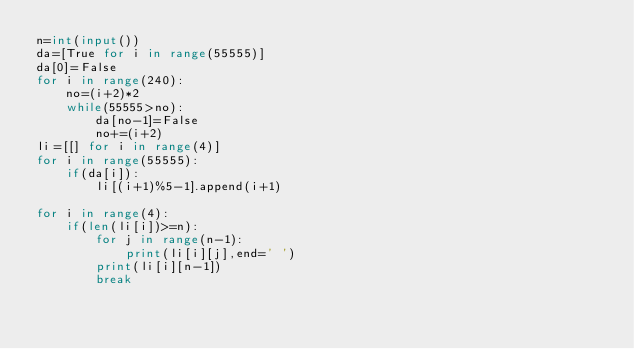Convert code to text. <code><loc_0><loc_0><loc_500><loc_500><_Python_>n=int(input())
da=[True for i in range(55555)]
da[0]=False
for i in range(240):
    no=(i+2)*2
    while(55555>no):
        da[no-1]=False
        no+=(i+2)
li=[[] for i in range(4)]
for i in range(55555):
    if(da[i]):
        li[(i+1)%5-1].append(i+1)

for i in range(4):
    if(len(li[i])>=n):
        for j in range(n-1):
            print(li[i][j],end=' ')
        print(li[i][n-1])
        break</code> 